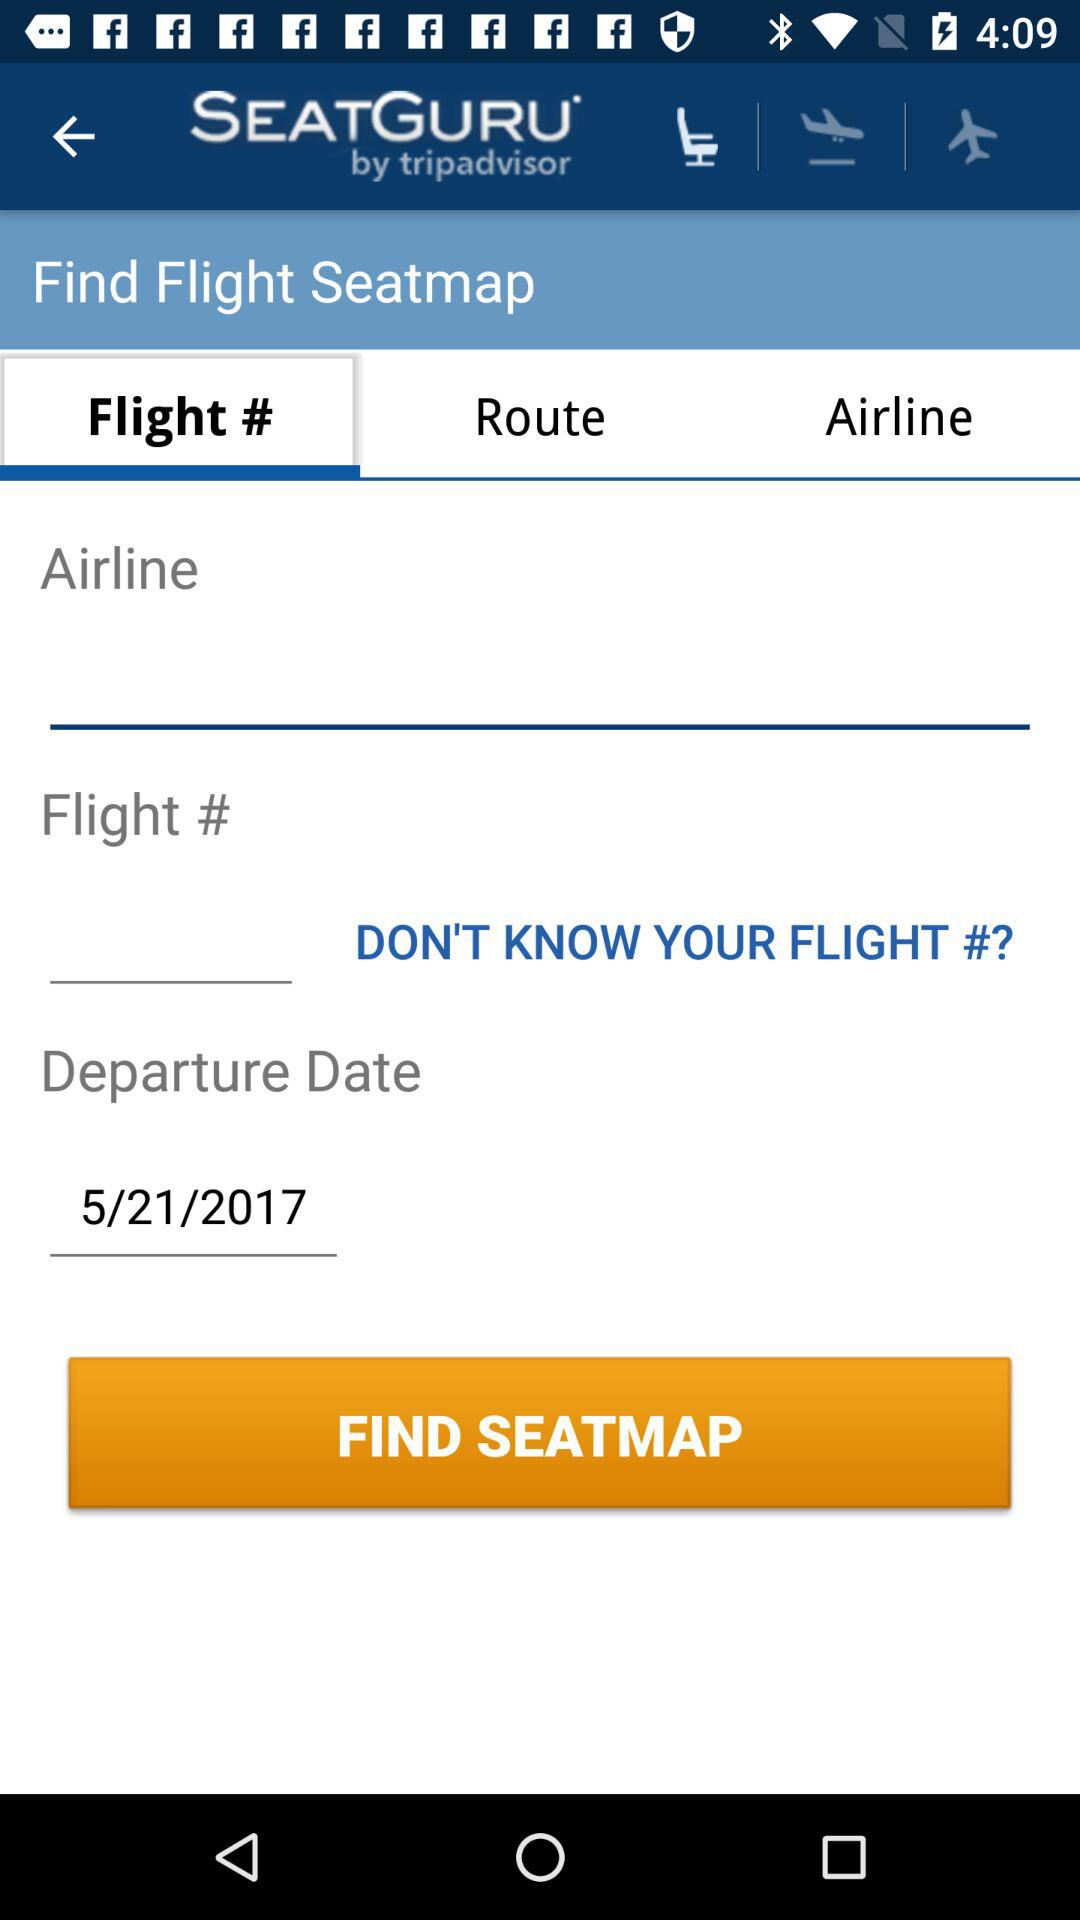What is the name of the application? The name of the application is "SEATGURU". 